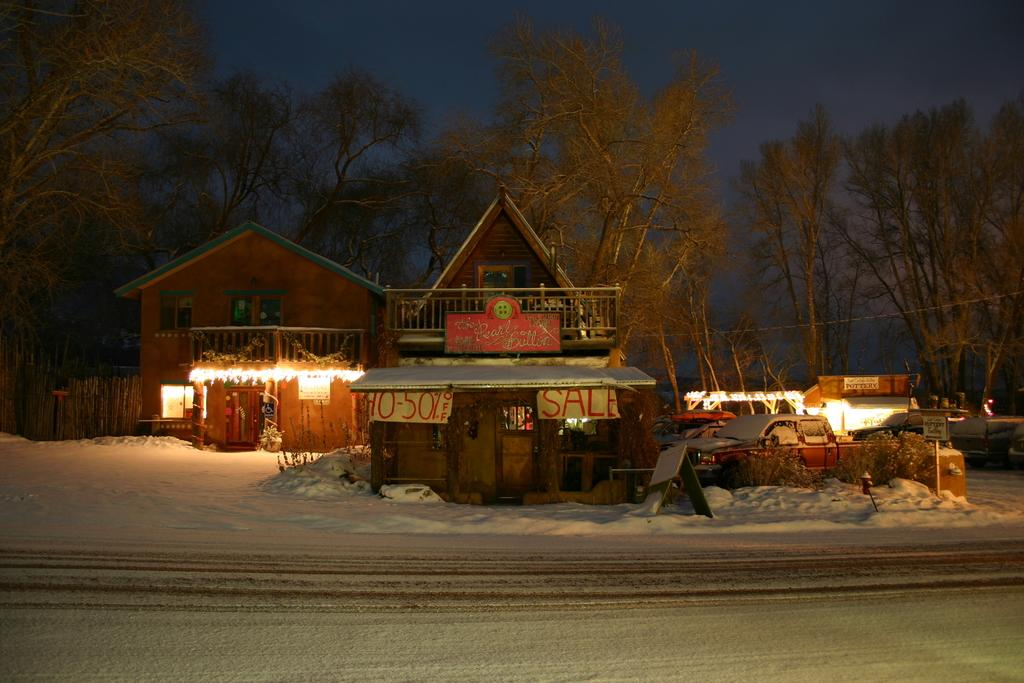How many houses can be seen in the image? There are two houses in the image. What else is present in the image besides the houses? There are vehicles, trees, and the sky visible in the image. What is the condition of the road in the image? The road is covered with snow in the image. Where is the secretary sitting in the image? There is no secretary present in the image. What type of playground equipment can be seen in the image? There is no playground equipment present in the image. 